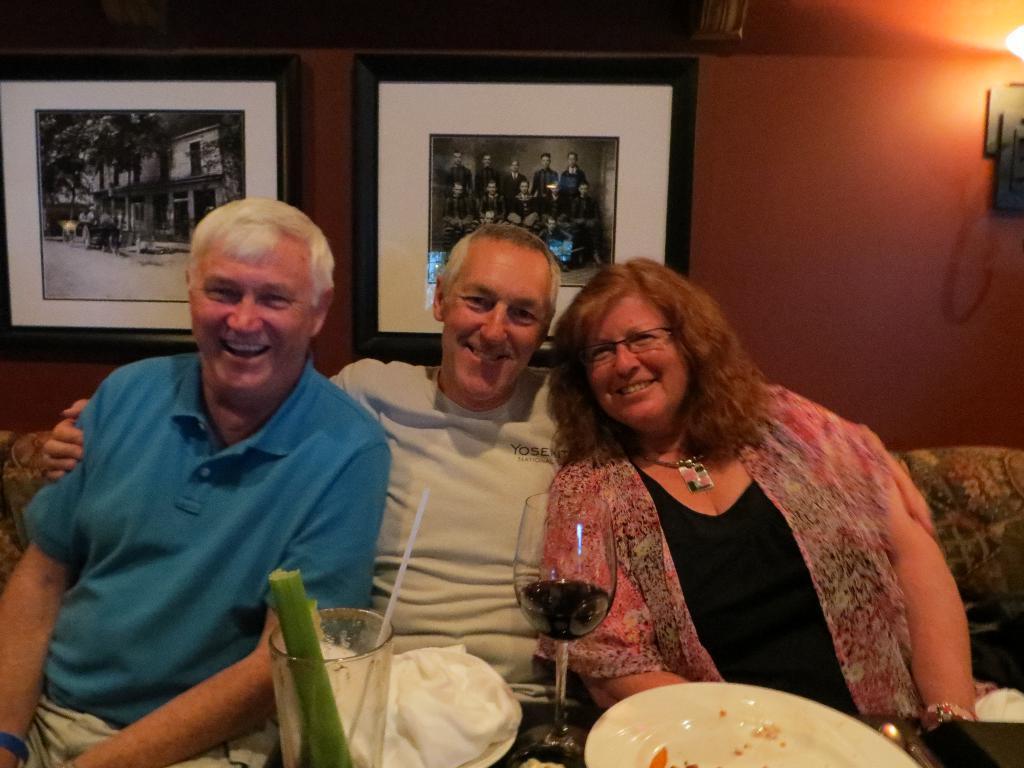In one or two sentences, can you explain what this image depicts? In this picture there are two old man sitting on the sofa, smiling and giving a pose in the camera. Beside there is a old woman wearing pink color top and black t-shirts smiling and giving a pose. In the front there is a white plate and wine glass. In the background we can see the brown wall with two photo frames. 